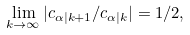Convert formula to latex. <formula><loc_0><loc_0><loc_500><loc_500>\lim _ { k \rightarrow \infty } | c _ { \alpha | k + 1 } / c _ { \alpha | k } | = 1 / 2 ,</formula> 